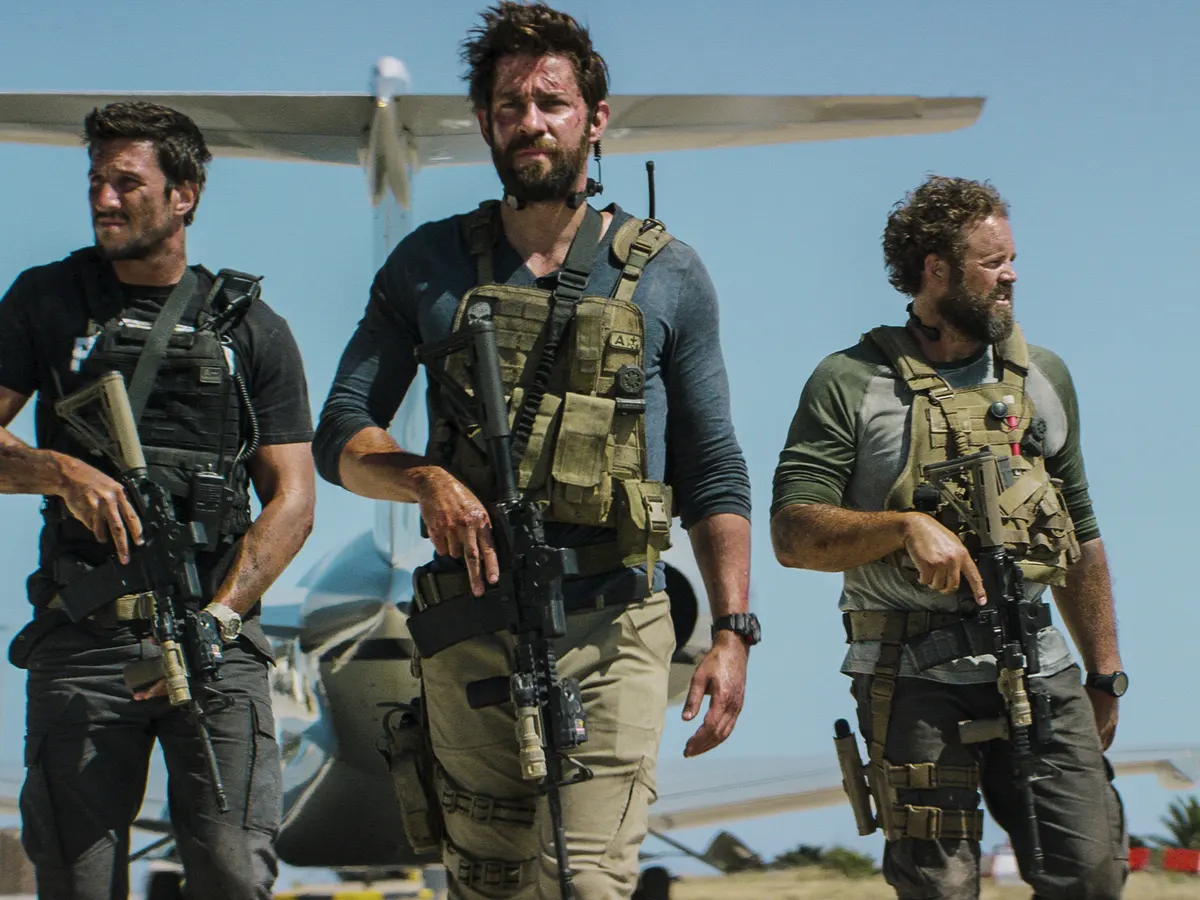Explain the visual content of the image in great detail. The image captures a trio of individuals outfitted in tactical gear, which includes beige vests, holstered sidearms, and rifles in hand. Positioned in the foreground and striding towards the camera, the central figure exudes an air of intense concentration and command. Accompanying him on each side, the other members exhibit similar focus and readiness. In the background, the presence of a small aircraft on a runway set against the clear blue sky hints at a military or operational setting. Their cohesive appearance and gear denote a scenario probably related to a special forces mission or a high-stakes operative task. 